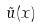Convert formula to latex. <formula><loc_0><loc_0><loc_500><loc_500>\tilde { u } ( x )</formula> 